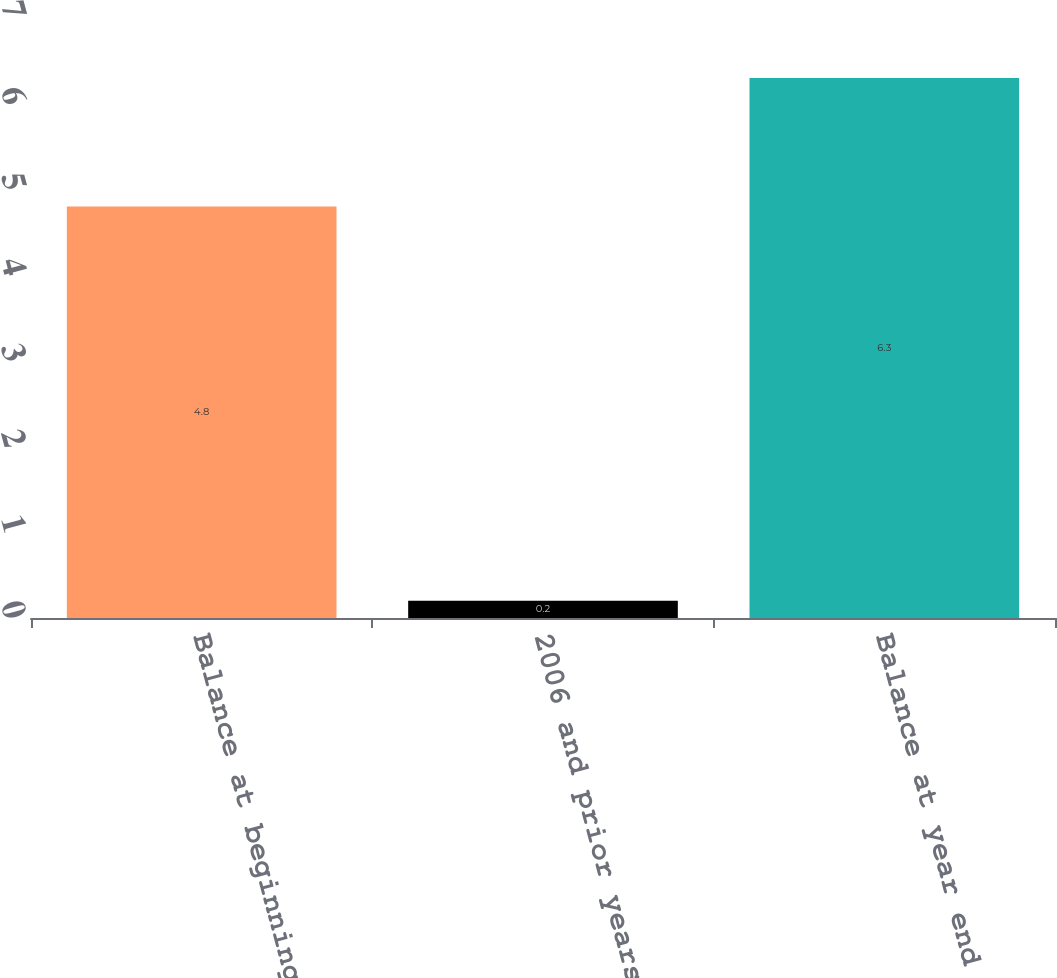Convert chart. <chart><loc_0><loc_0><loc_500><loc_500><bar_chart><fcel>Balance at beginning of year<fcel>2006 and prior years<fcel>Balance at year end<nl><fcel>4.8<fcel>0.2<fcel>6.3<nl></chart> 